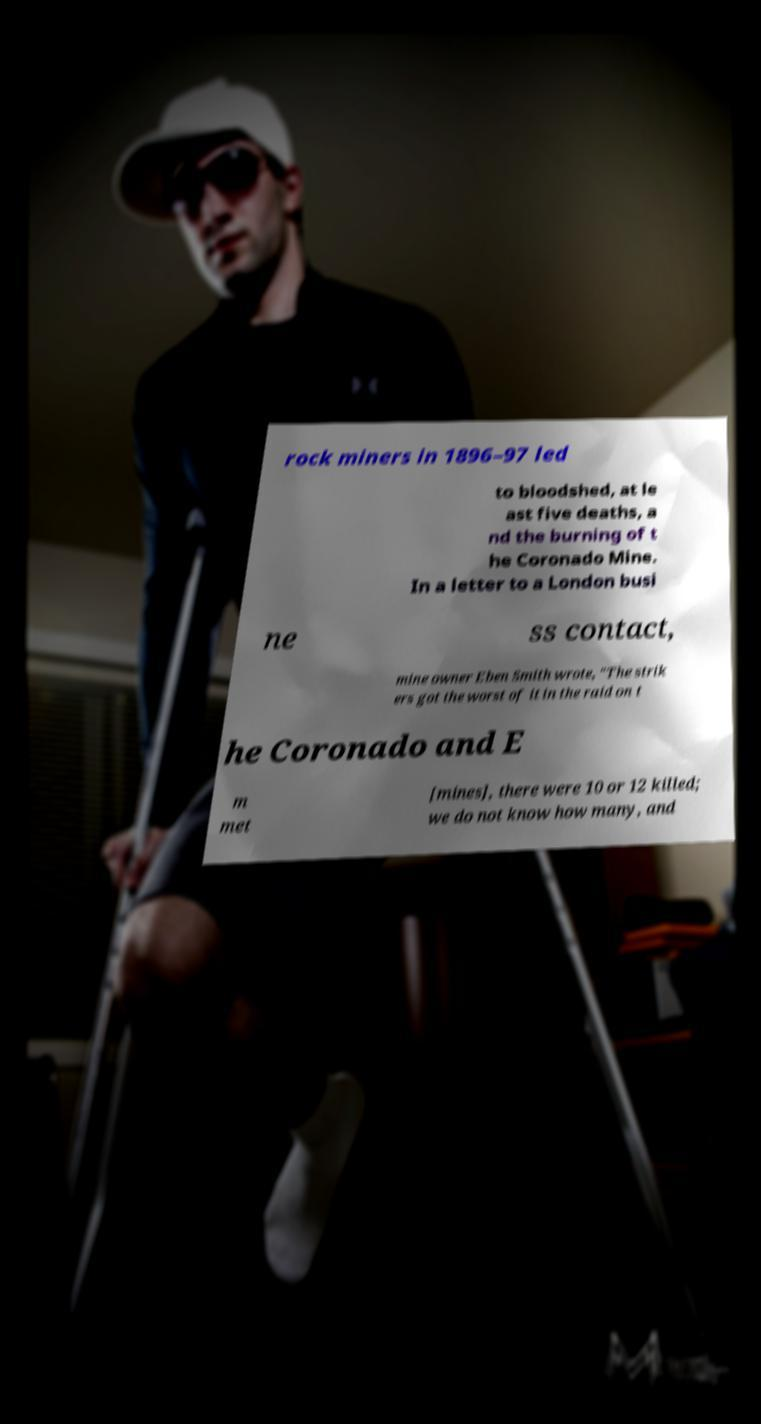Can you read and provide the text displayed in the image?This photo seems to have some interesting text. Can you extract and type it out for me? rock miners in 1896–97 led to bloodshed, at le ast five deaths, a nd the burning of t he Coronado Mine. In a letter to a London busi ne ss contact, mine owner Eben Smith wrote, "The strik ers got the worst of it in the raid on t he Coronado and E m met [mines], there were 10 or 12 killed; we do not know how many, and 